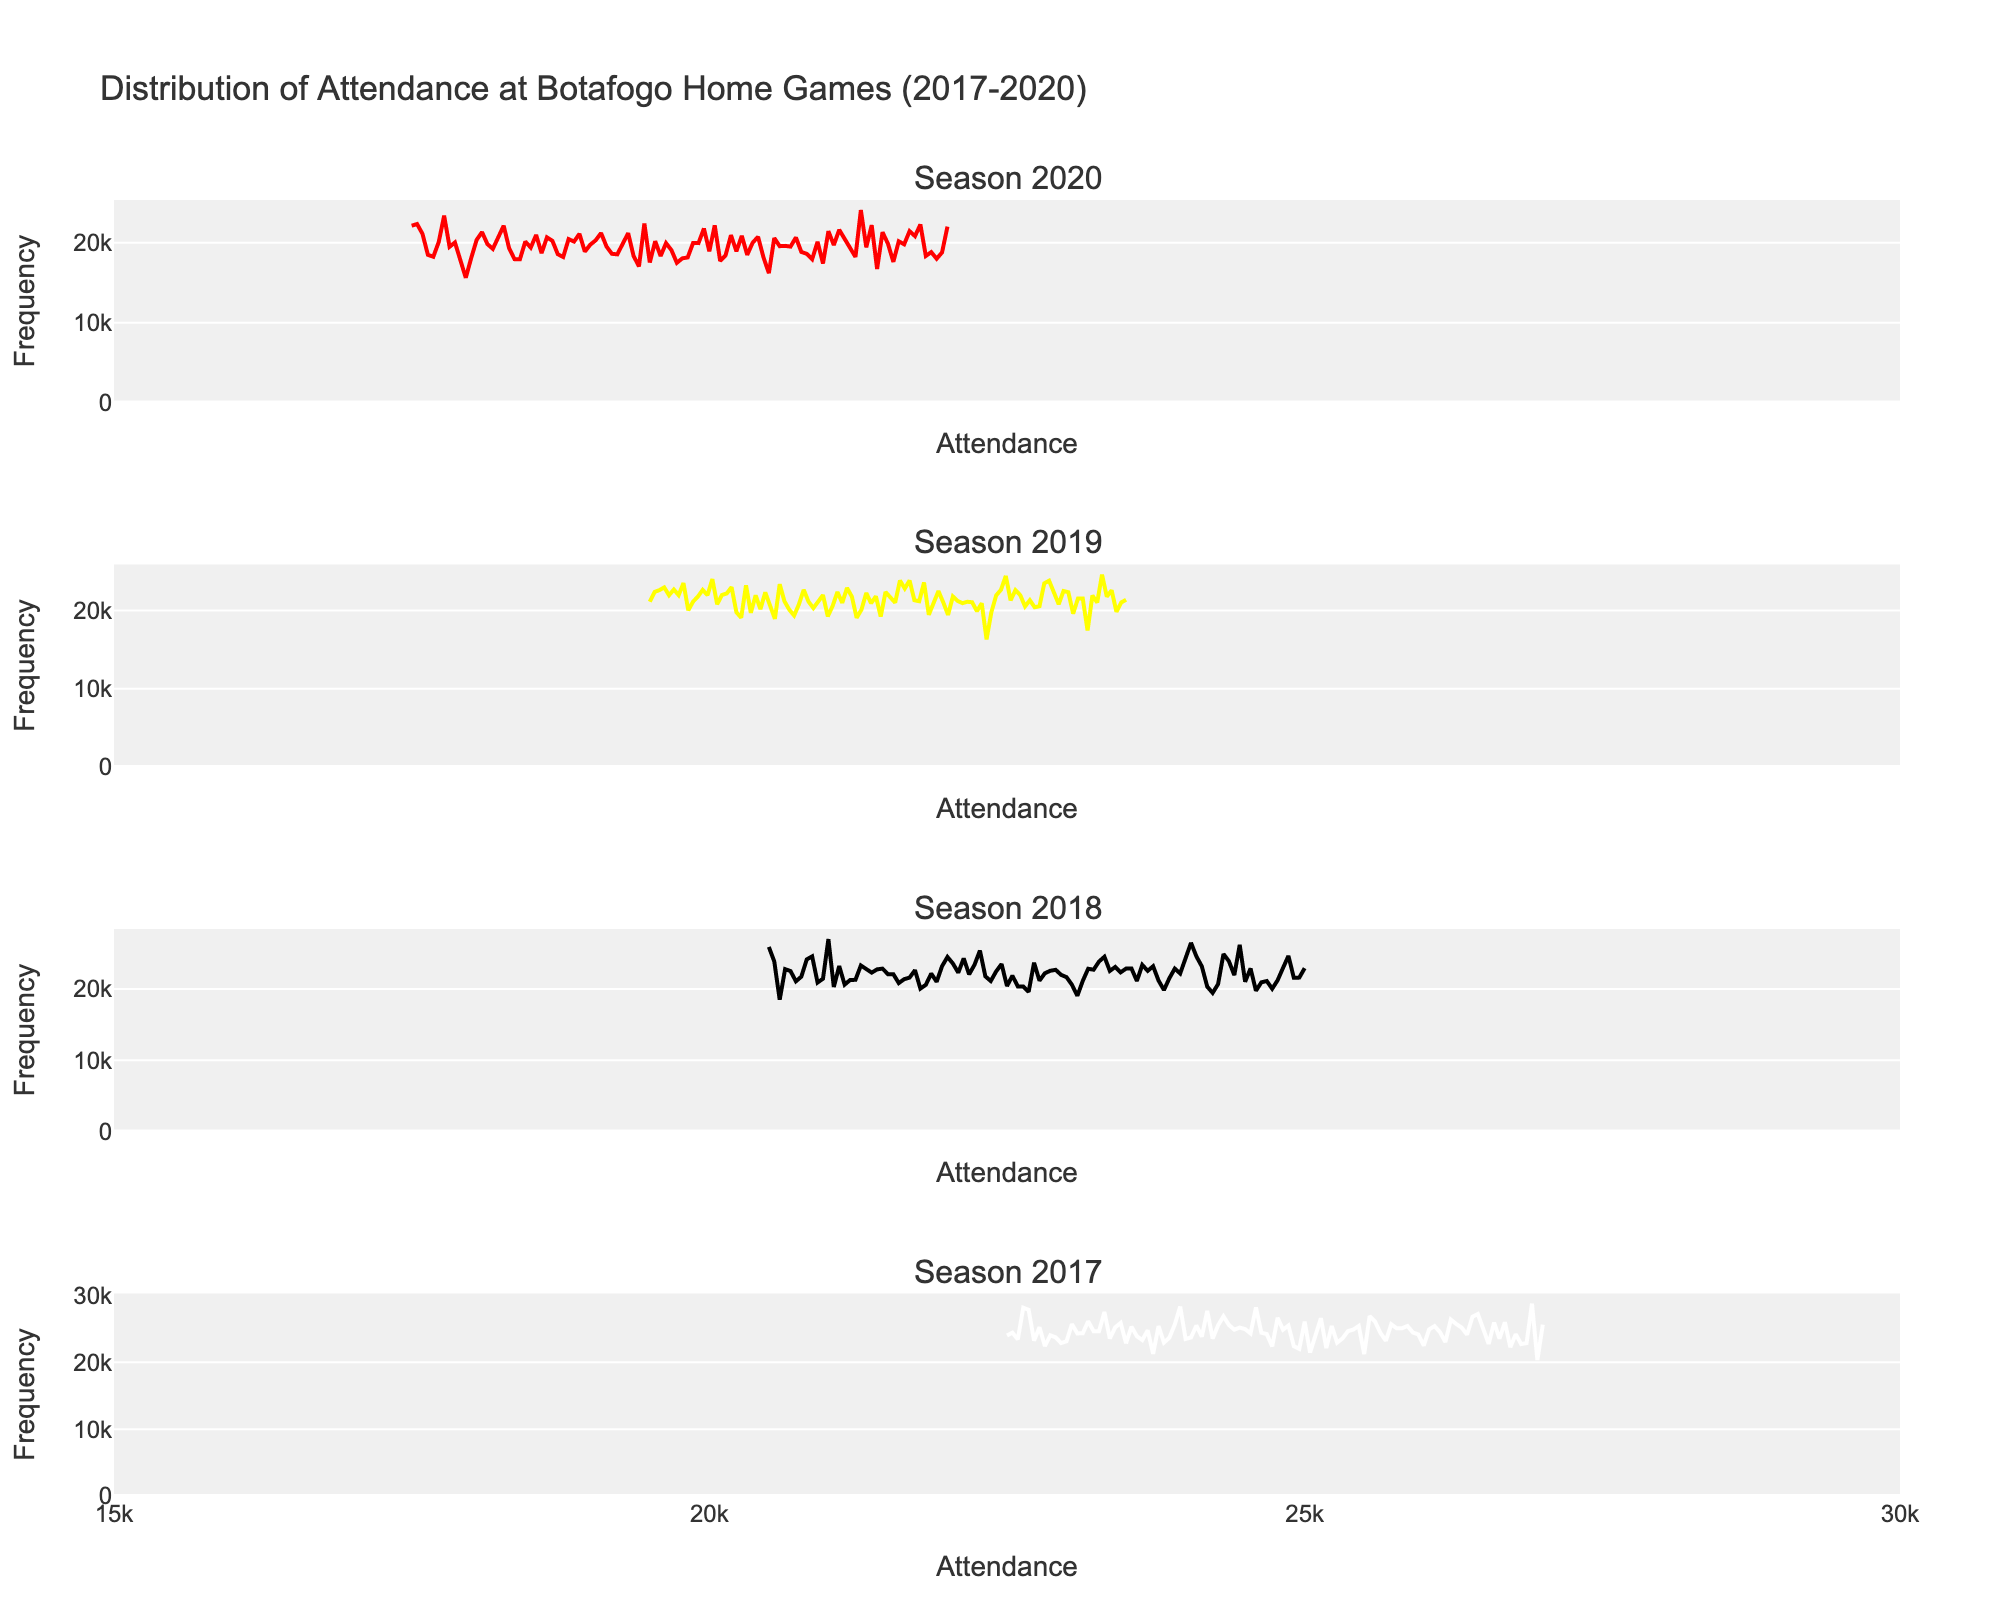What is the range of attendance values shown on the x-axis? By looking at the x-axis, we see the labels range from 15000 to 30000.
Answer: 15000 to 30000 Which season has the highest recorded attendance at Botafogo home games? By examining the peaks in each subplot, the tallest peak is in the 2017 season, indicating the highest recorded attendance.
Answer: 2017 What is the general trend in attendance from 2017 to 2020? By comparing subplots for each season, we observe the peaks decrease from 2017 to 2020, suggesting a declining trend.
Answer: Declining Which season has the most concentrated attendance values? The 2020 subplot shows attendance values clustered closely together, indicating high concentration.
Answer: 2020 Which season has the highest frequency of attendance between 25000 and 30000? By looking at the histograms, the 2017 season prominently shows frequencies in the 25000 to 30000 range.
Answer: 2017 Is there any season where the attendance dipped below 18000? The attendance values in the 2020 season dip below 18000, as seen in the histogram.
Answer: Yes, 2020 Compare the distribution shape between 2018 and 2019. Which one is more uniformly distributed? The 2019 histogram bars are more evenly distributed compared to 2018, which shows a more skewed distribution.
Answer: 2019 Which seasons have the lowest KDE peaks? The KDE lines show that the lowest peaks appear in the 2020 season.
Answer: 2020 Does the attendance in 2019 show any significant deviation from the mean compared to 2017? The 2019 distribution appears less spread out around the mean compared to 2017, indicating less deviation.
Answer: Less deviation in 2019 